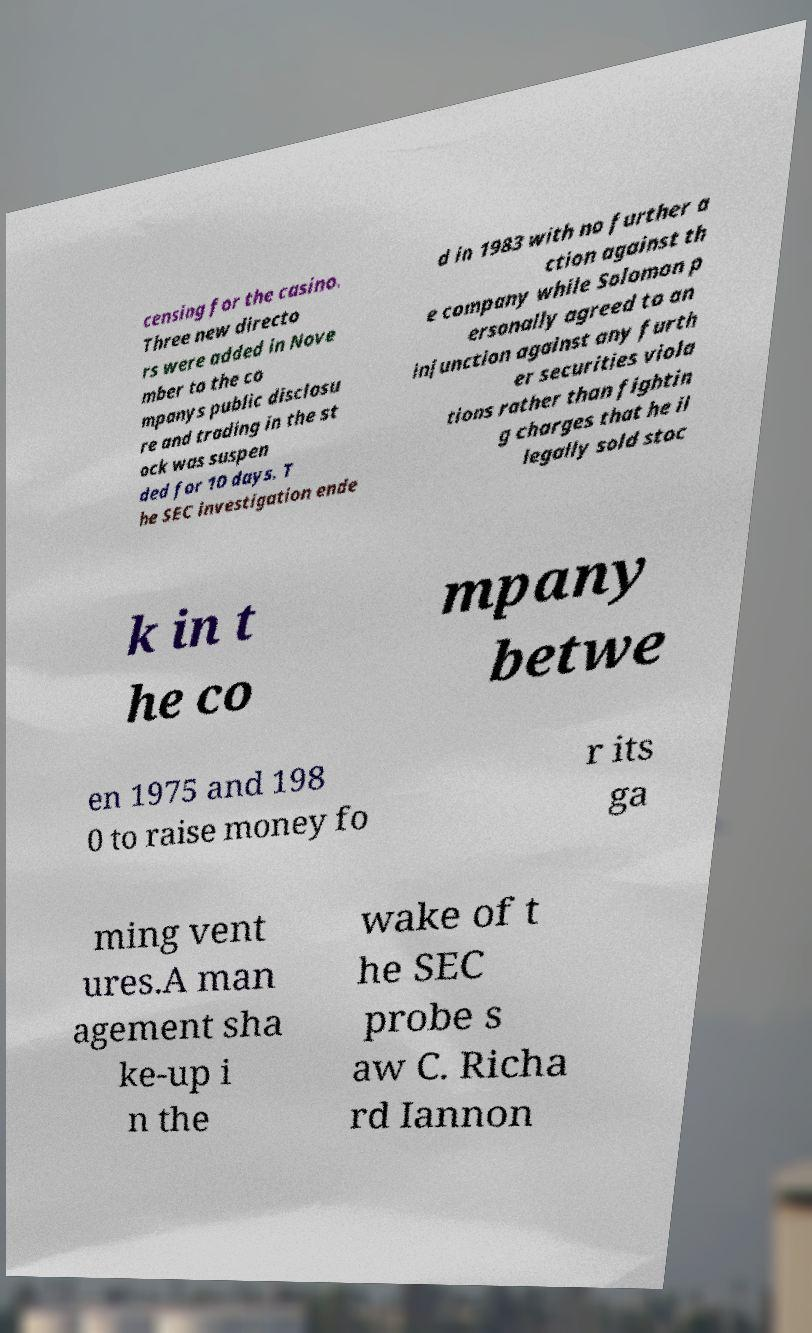Please read and relay the text visible in this image. What does it say? censing for the casino. Three new directo rs were added in Nove mber to the co mpanys public disclosu re and trading in the st ock was suspen ded for 10 days. T he SEC investigation ende d in 1983 with no further a ction against th e company while Solomon p ersonally agreed to an injunction against any furth er securities viola tions rather than fightin g charges that he il legally sold stoc k in t he co mpany betwe en 1975 and 198 0 to raise money fo r its ga ming vent ures.A man agement sha ke-up i n the wake of t he SEC probe s aw C. Richa rd Iannon 